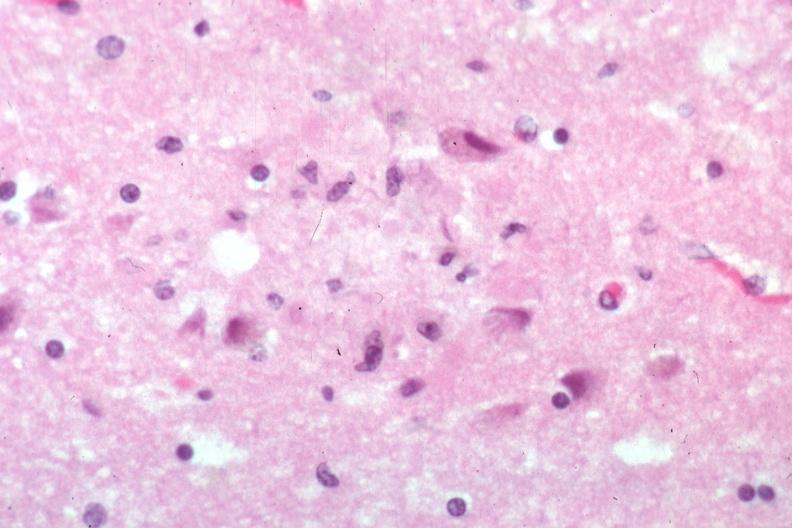s case of peritonitis slide present?
Answer the question using a single word or phrase. No 